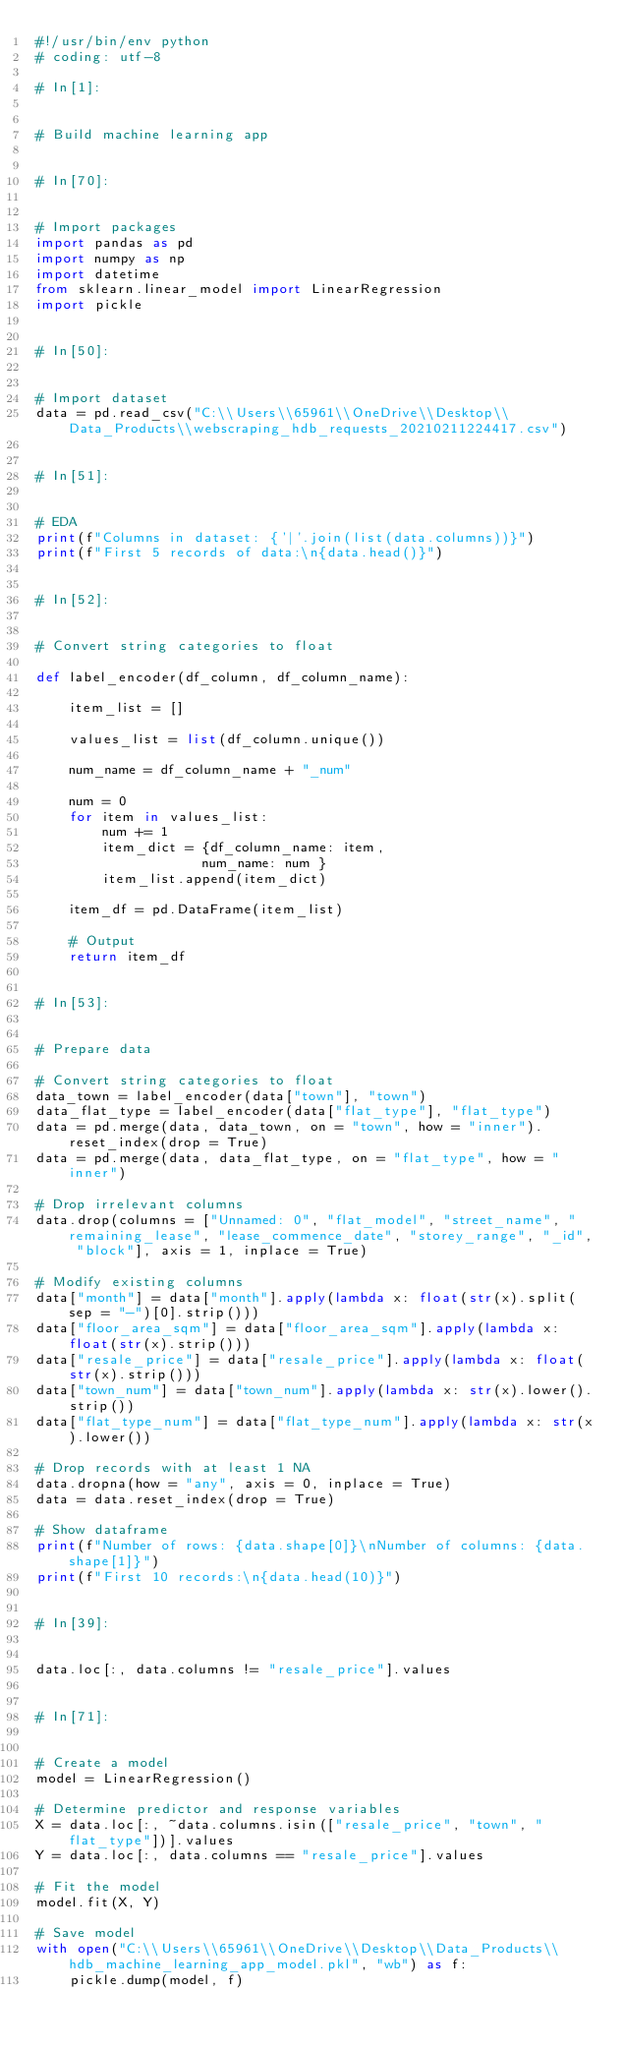Convert code to text. <code><loc_0><loc_0><loc_500><loc_500><_Python_>#!/usr/bin/env python
# coding: utf-8

# In[1]:


# Build machine learning app


# In[70]:


# Import packages
import pandas as pd
import numpy as np
import datetime
from sklearn.linear_model import LinearRegression
import pickle


# In[50]:


# Import dataset
data = pd.read_csv("C:\\Users\\65961\\OneDrive\\Desktop\\Data_Products\\webscraping_hdb_requests_20210211224417.csv")


# In[51]:


# EDA
print(f"Columns in dataset: {'|'.join(list(data.columns))}")
print(f"First 5 records of data:\n{data.head()}")


# In[52]:


# Convert string categories to float

def label_encoder(df_column, df_column_name):
    
    item_list = []
    
    values_list = list(df_column.unique())
    
    num_name = df_column_name + "_num"
    
    num = 0
    for item in values_list:
        num += 1
        item_dict = {df_column_name: item,
                    num_name: num }
        item_list.append(item_dict)
    
    item_df = pd.DataFrame(item_list)
    
    # Output
    return item_df


# In[53]:


# Prepare data

# Convert string categories to float
data_town = label_encoder(data["town"], "town")
data_flat_type = label_encoder(data["flat_type"], "flat_type")
data = pd.merge(data, data_town, on = "town", how = "inner").reset_index(drop = True)
data = pd.merge(data, data_flat_type, on = "flat_type", how = "inner")

# Drop irrelevant columns
data.drop(columns = ["Unnamed: 0", "flat_model", "street_name", "remaining_lease", "lease_commence_date", "storey_range", "_id", "block"], axis = 1, inplace = True)

# Modify existing columns
data["month"] = data["month"].apply(lambda x: float(str(x).split(sep = "-")[0].strip()))
data["floor_area_sqm"] = data["floor_area_sqm"].apply(lambda x: float(str(x).strip()))
data["resale_price"] = data["resale_price"].apply(lambda x: float(str(x).strip()))
data["town_num"] = data["town_num"].apply(lambda x: str(x).lower().strip())
data["flat_type_num"] = data["flat_type_num"].apply(lambda x: str(x).lower())

# Drop records with at least 1 NA
data.dropna(how = "any", axis = 0, inplace = True)
data = data.reset_index(drop = True)

# Show dataframe
print(f"Number of rows: {data.shape[0]}\nNumber of columns: {data.shape[1]}")
print(f"First 10 records:\n{data.head(10)}")


# In[39]:


data.loc[:, data.columns != "resale_price"].values


# In[71]:


# Create a model
model = LinearRegression()

# Determine predictor and response variables
X = data.loc[:, ~data.columns.isin(["resale_price", "town", "flat_type"])].values
Y = data.loc[:, data.columns == "resale_price"].values

# Fit the model
model.fit(X, Y)

# Save model
with open("C:\\Users\\65961\\OneDrive\\Desktop\\Data_Products\\hdb_machine_learning_app_model.pkl", "wb") as f:
    pickle.dump(model, f)
</code> 